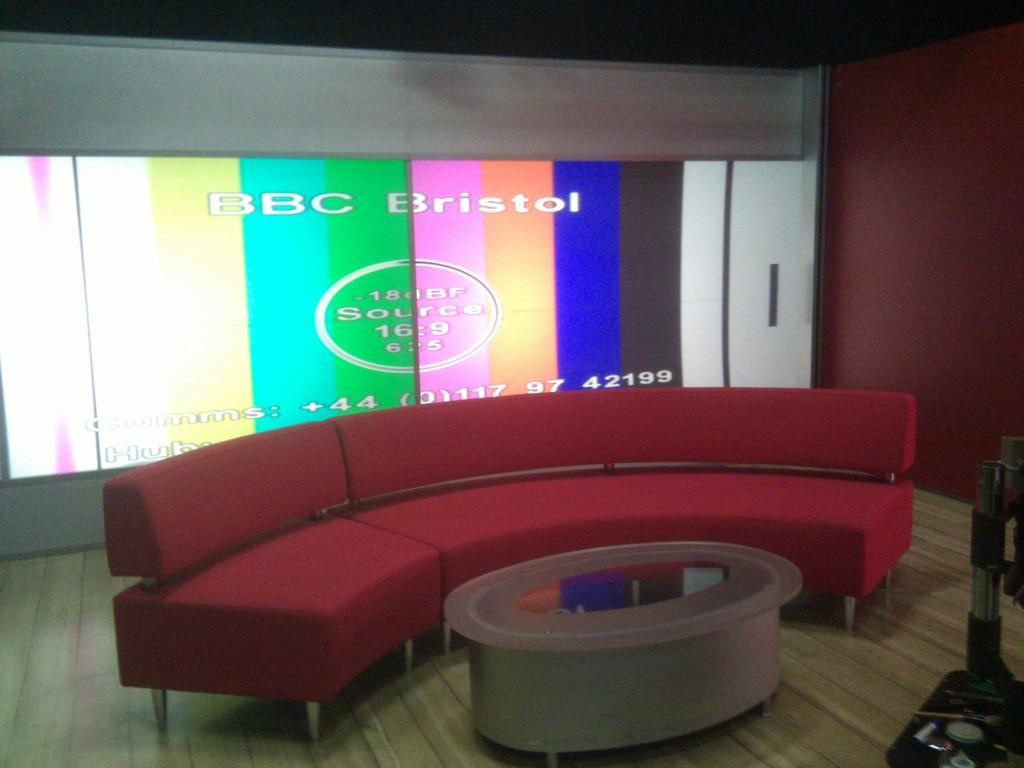What is the main piece of furniture in the image? There is a red color sofa at the center of the image. What is placed in front of the sofa? There is a table in front of the sofa. What can be seen at the left side of the image? There is a projector screen at the left side of the image. How many ghosts are sitting on the red sofa in the image? There are no ghosts present in the image. What type of men can be seen interacting with the projector screen in the image? There are no men present in the image; it only features a red sofa, a table, and a projector screen. 